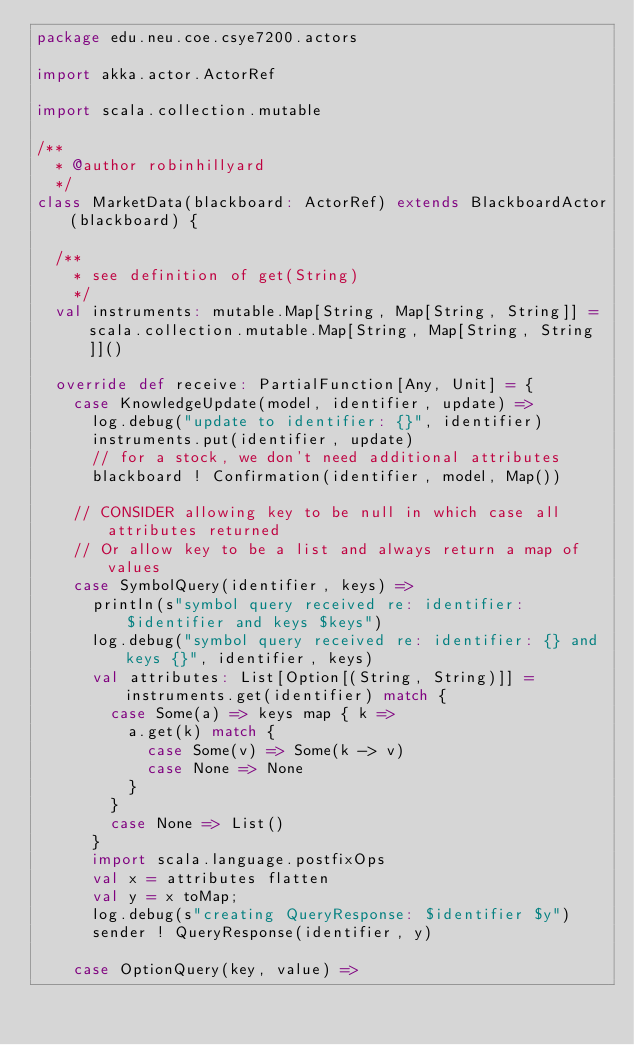<code> <loc_0><loc_0><loc_500><loc_500><_Scala_>package edu.neu.coe.csye7200.actors

import akka.actor.ActorRef

import scala.collection.mutable

/**
  * @author robinhillyard
  */
class MarketData(blackboard: ActorRef) extends BlackboardActor(blackboard) {

  /**
    * see definition of get(String)
    */
  val instruments: mutable.Map[String, Map[String, String]] = scala.collection.mutable.Map[String, Map[String, String]]()

  override def receive: PartialFunction[Any, Unit] = {
    case KnowledgeUpdate(model, identifier, update) =>
      log.debug("update to identifier: {}", identifier)
      instruments.put(identifier, update)
      // for a stock, we don't need additional attributes
      blackboard ! Confirmation(identifier, model, Map())

    // CONSIDER allowing key to be null in which case all attributes returned
    // Or allow key to be a list and always return a map of values
    case SymbolQuery(identifier, keys) =>
      println(s"symbol query received re: identifier: $identifier and keys $keys")
      log.debug("symbol query received re: identifier: {} and keys {}", identifier, keys)
      val attributes: List[Option[(String, String)]] = instruments.get(identifier) match {
        case Some(a) => keys map { k =>
          a.get(k) match {
            case Some(v) => Some(k -> v)
            case None => None
          }
        }
        case None => List()
      }
      import scala.language.postfixOps
      val x = attributes flatten
      val y = x toMap;
      log.debug(s"creating QueryResponse: $identifier $y")
      sender ! QueryResponse(identifier, y)

    case OptionQuery(key, value) =></code> 